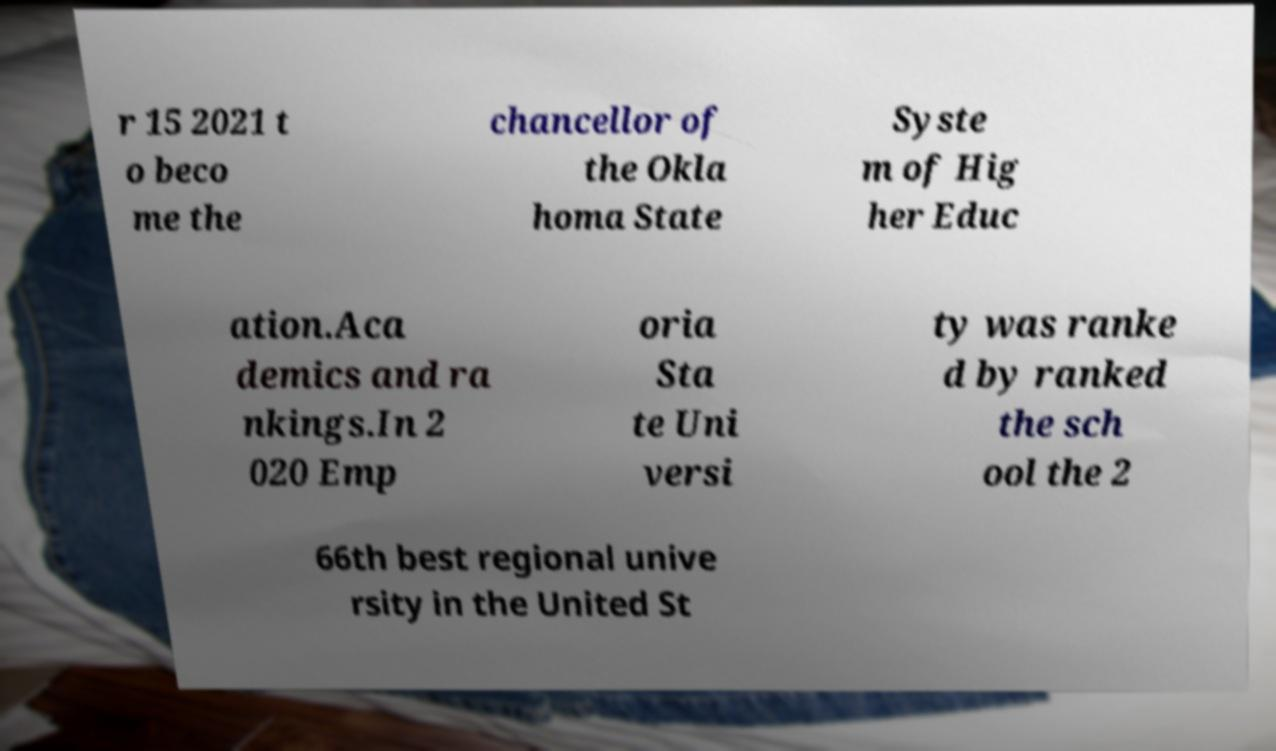What messages or text are displayed in this image? I need them in a readable, typed format. r 15 2021 t o beco me the chancellor of the Okla homa State Syste m of Hig her Educ ation.Aca demics and ra nkings.In 2 020 Emp oria Sta te Uni versi ty was ranke d by ranked the sch ool the 2 66th best regional unive rsity in the United St 